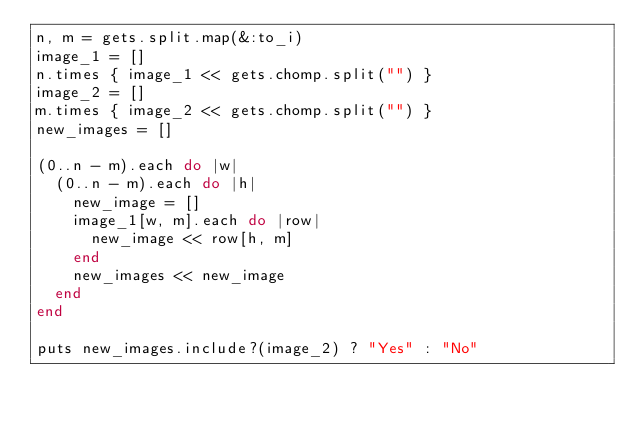Convert code to text. <code><loc_0><loc_0><loc_500><loc_500><_Ruby_>n, m = gets.split.map(&:to_i)
image_1 = []
n.times { image_1 << gets.chomp.split("") }
image_2 = []
m.times { image_2 << gets.chomp.split("") }
new_images = []

(0..n - m).each do |w|
  (0..n - m).each do |h|
    new_image = []
    image_1[w, m].each do |row|
      new_image << row[h, m]
    end
    new_images << new_image
  end
end

puts new_images.include?(image_2) ? "Yes" : "No"
</code> 